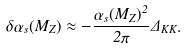<formula> <loc_0><loc_0><loc_500><loc_500>\delta \alpha _ { s } ( M _ { Z } ) \approx - \frac { \alpha _ { s } ( M _ { Z } ) ^ { 2 } } { 2 \pi } \Delta _ { K K } .</formula> 